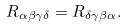Convert formula to latex. <formula><loc_0><loc_0><loc_500><loc_500>R _ { \alpha \beta \gamma \delta } = R _ { \delta \gamma \beta \alpha } .</formula> 